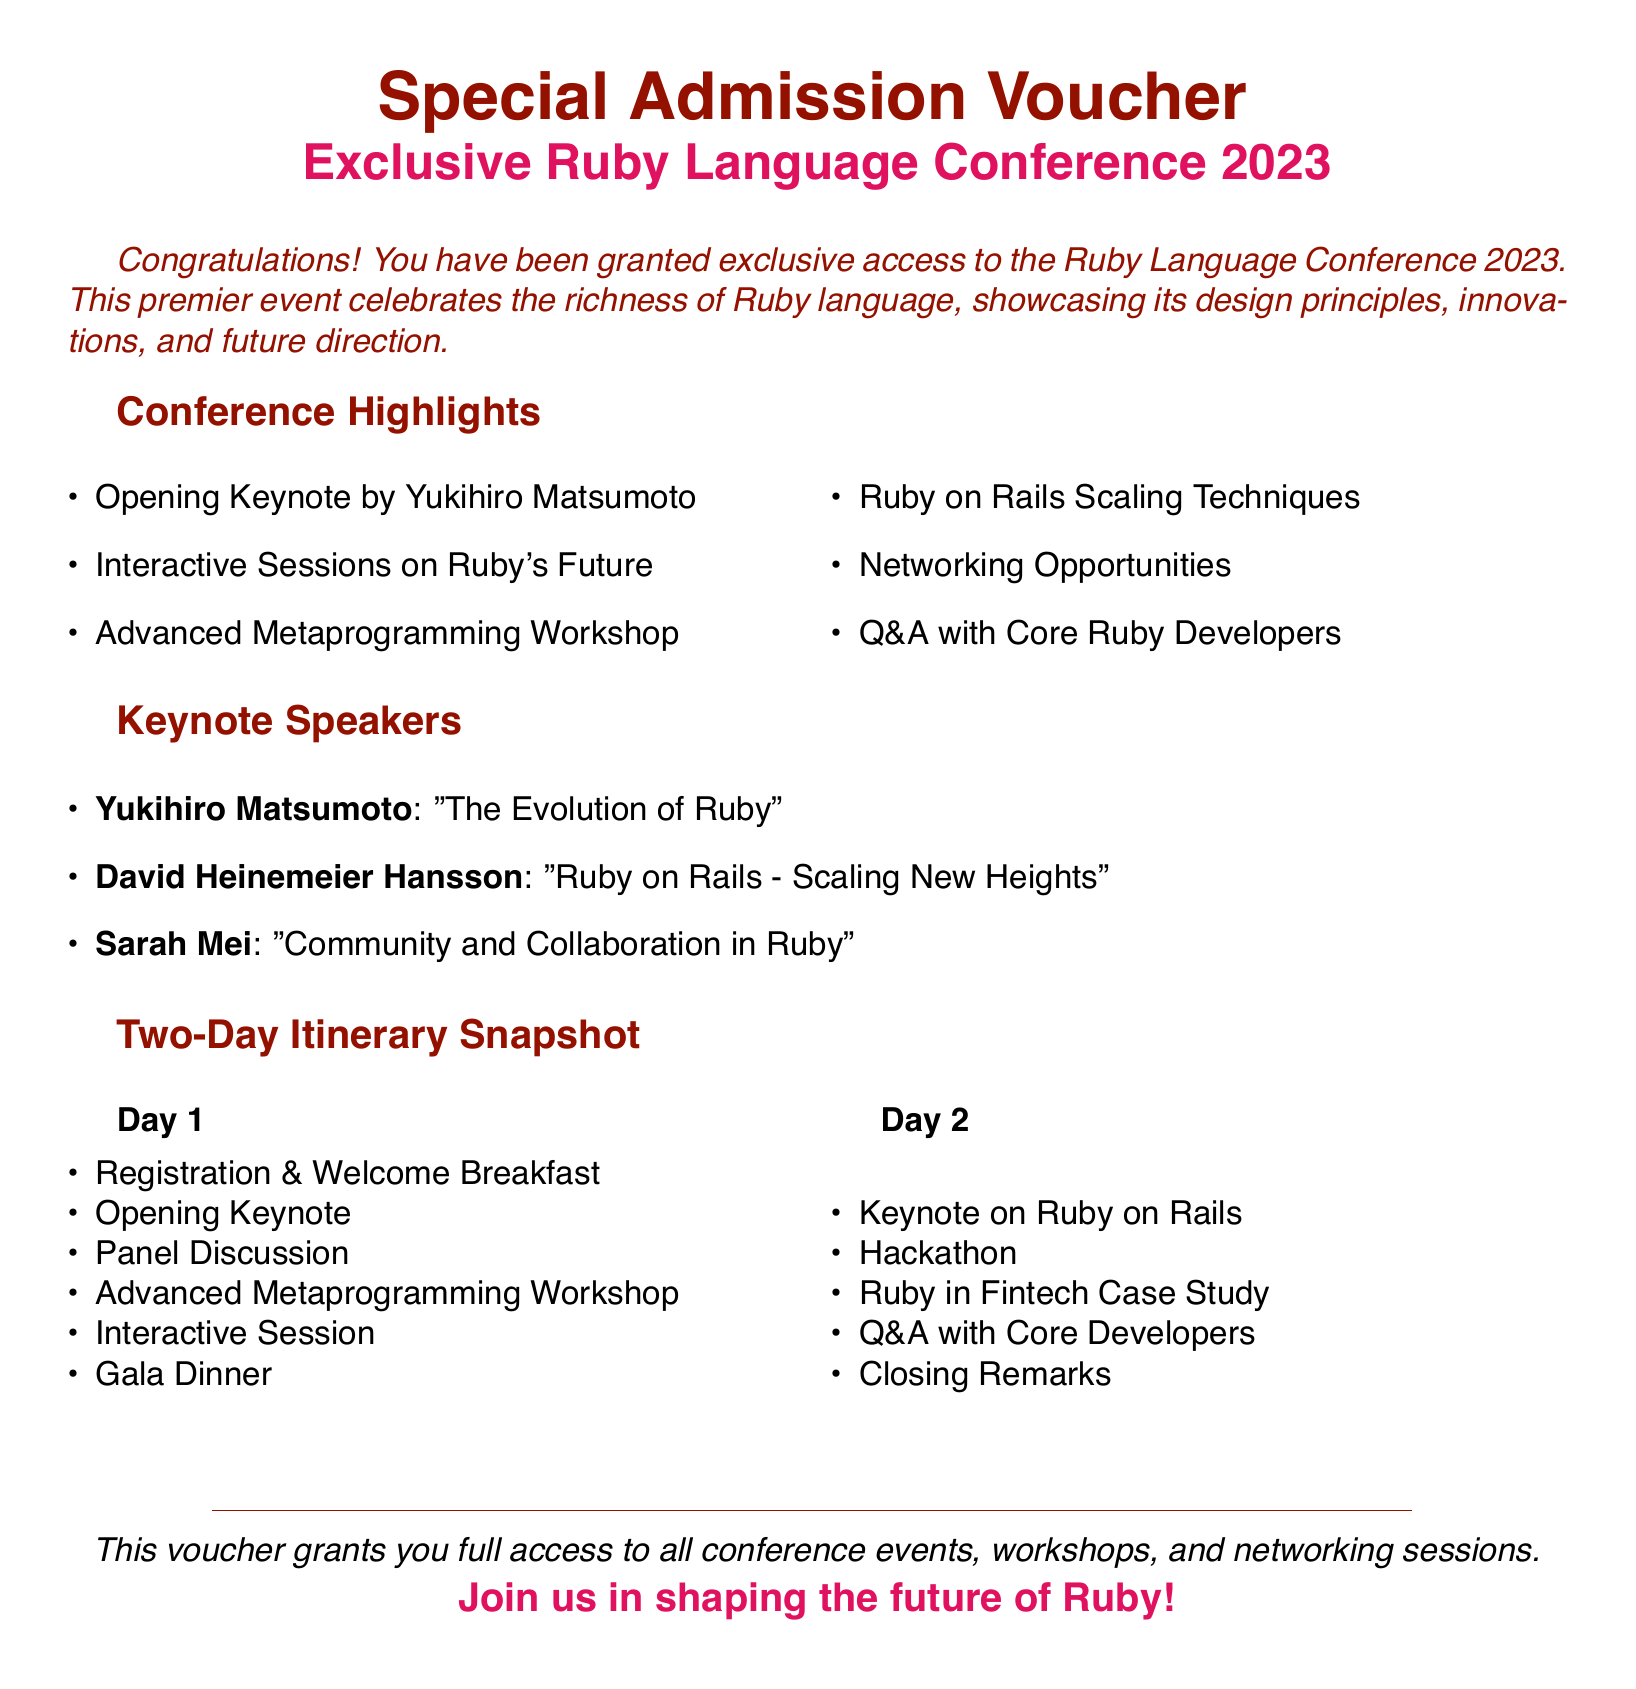What is the title of the event? The title of the event is specified prominently at the top of the document.
Answer: Exclusive Ruby Language Conference 2023 Who is the opening keynote speaker? The document lists Yukihiro Matsumoto as the opening keynote speaker under the conference highlights section.
Answer: Yukihiro Matsumoto What is one topic covered by David Heinemeier Hansson? The document mentions his talk in the keynote speakers section regarding scaling.
Answer: Ruby on Rails - Scaling New Heights How many days does the conference last? The itinerary specifies activities for two days, indicating the duration of the conference.
Answer: Two days What are the first activities on Day 1? The itinerary lists the starting events on Day 1 under the respective section.
Answer: Registration & Welcome Breakfast What is one type of session offered during the conference? The highlights section mentions various session types available at the conference.
Answer: Advanced Metaprogramming Workshop Which color scheme is used in the document? The document specifically defines a color palette for titles and text through its code section.
Answer: Rubydark and Rubylight What does the voucher grant access to? The document explicitly states the access rights granted by the voucher at the bottom.
Answer: All conference events, workshops, and networking sessions 